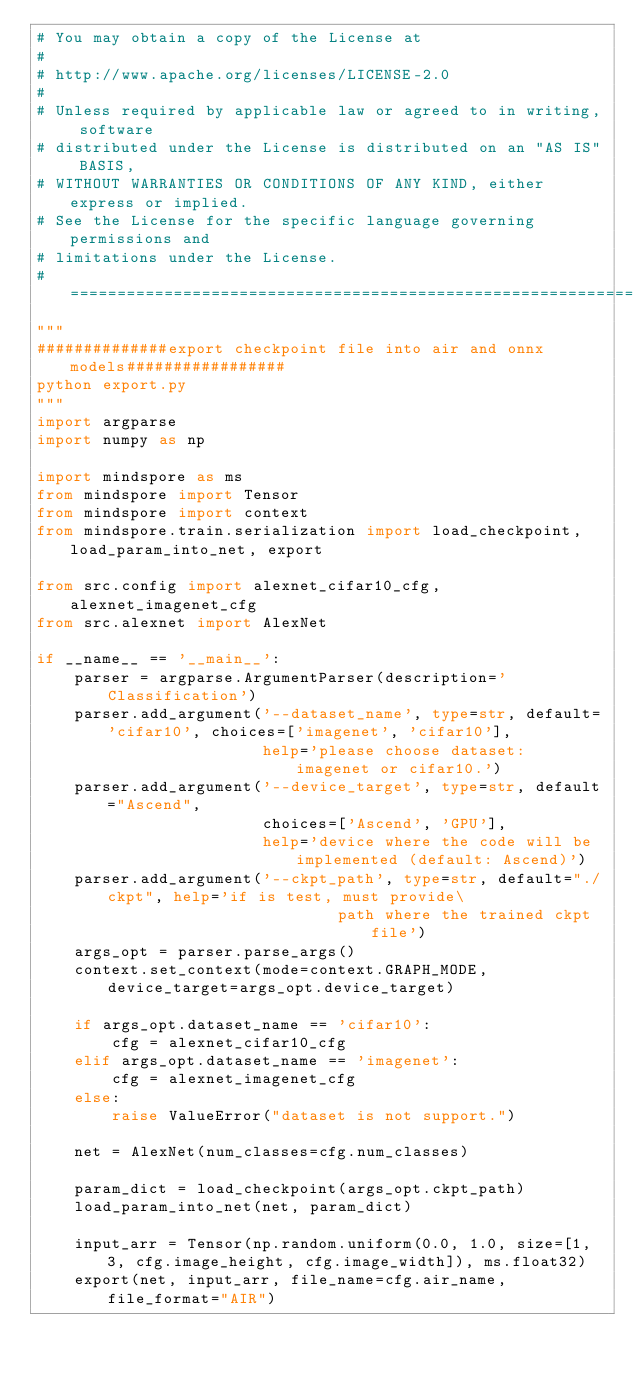<code> <loc_0><loc_0><loc_500><loc_500><_Python_># You may obtain a copy of the License at
#
# http://www.apache.org/licenses/LICENSE-2.0
#
# Unless required by applicable law or agreed to in writing, software
# distributed under the License is distributed on an "AS IS" BASIS,
# WITHOUT WARRANTIES OR CONDITIONS OF ANY KIND, either express or implied.
# See the License for the specific language governing permissions and
# limitations under the License.
# ============================================================================
"""
##############export checkpoint file into air and onnx models#################
python export.py
"""
import argparse
import numpy as np

import mindspore as ms
from mindspore import Tensor
from mindspore import context
from mindspore.train.serialization import load_checkpoint, load_param_into_net, export

from src.config import alexnet_cifar10_cfg, alexnet_imagenet_cfg
from src.alexnet import AlexNet

if __name__ == '__main__':
    parser = argparse.ArgumentParser(description='Classification')
    parser.add_argument('--dataset_name', type=str, default='cifar10', choices=['imagenet', 'cifar10'],
                        help='please choose dataset: imagenet or cifar10.')
    parser.add_argument('--device_target', type=str, default="Ascend",
                        choices=['Ascend', 'GPU'],
                        help='device where the code will be implemented (default: Ascend)')
    parser.add_argument('--ckpt_path', type=str, default="./ckpt", help='if is test, must provide\
                                path where the trained ckpt file')
    args_opt = parser.parse_args()
    context.set_context(mode=context.GRAPH_MODE, device_target=args_opt.device_target)

    if args_opt.dataset_name == 'cifar10':
        cfg = alexnet_cifar10_cfg
    elif args_opt.dataset_name == 'imagenet':
        cfg = alexnet_imagenet_cfg
    else:
        raise ValueError("dataset is not support.")

    net = AlexNet(num_classes=cfg.num_classes)

    param_dict = load_checkpoint(args_opt.ckpt_path)
    load_param_into_net(net, param_dict)

    input_arr = Tensor(np.random.uniform(0.0, 1.0, size=[1, 3, cfg.image_height, cfg.image_width]), ms.float32)
    export(net, input_arr, file_name=cfg.air_name, file_format="AIR")
</code> 